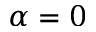<formula> <loc_0><loc_0><loc_500><loc_500>\alpha = 0</formula> 